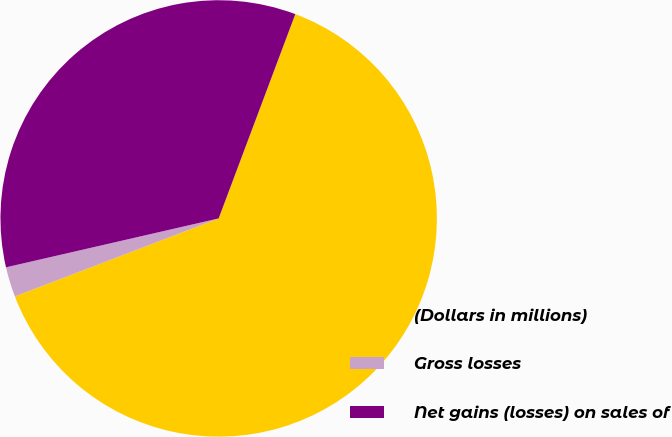Convert chart. <chart><loc_0><loc_0><loc_500><loc_500><pie_chart><fcel>(Dollars in millions)<fcel>Gross losses<fcel>Net gains (losses) on sales of<nl><fcel>63.47%<fcel>2.22%<fcel>34.31%<nl></chart> 